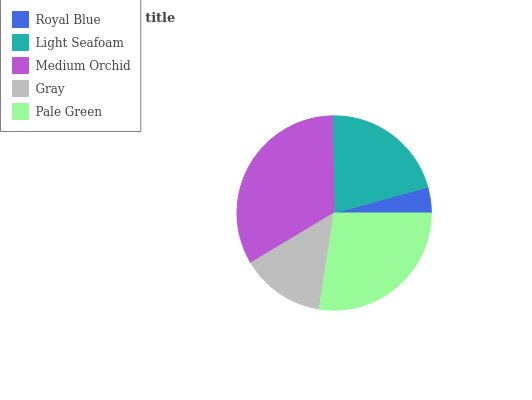Is Royal Blue the minimum?
Answer yes or no. Yes. Is Medium Orchid the maximum?
Answer yes or no. Yes. Is Light Seafoam the minimum?
Answer yes or no. No. Is Light Seafoam the maximum?
Answer yes or no. No. Is Light Seafoam greater than Royal Blue?
Answer yes or no. Yes. Is Royal Blue less than Light Seafoam?
Answer yes or no. Yes. Is Royal Blue greater than Light Seafoam?
Answer yes or no. No. Is Light Seafoam less than Royal Blue?
Answer yes or no. No. Is Light Seafoam the high median?
Answer yes or no. Yes. Is Light Seafoam the low median?
Answer yes or no. Yes. Is Pale Green the high median?
Answer yes or no. No. Is Medium Orchid the low median?
Answer yes or no. No. 